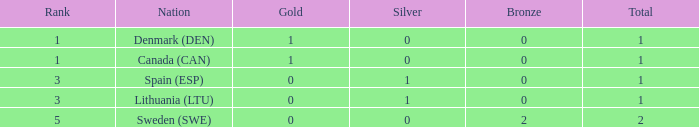How many bronze medals were secured when the total exceeds 1, and gold surpasses 0? None. 